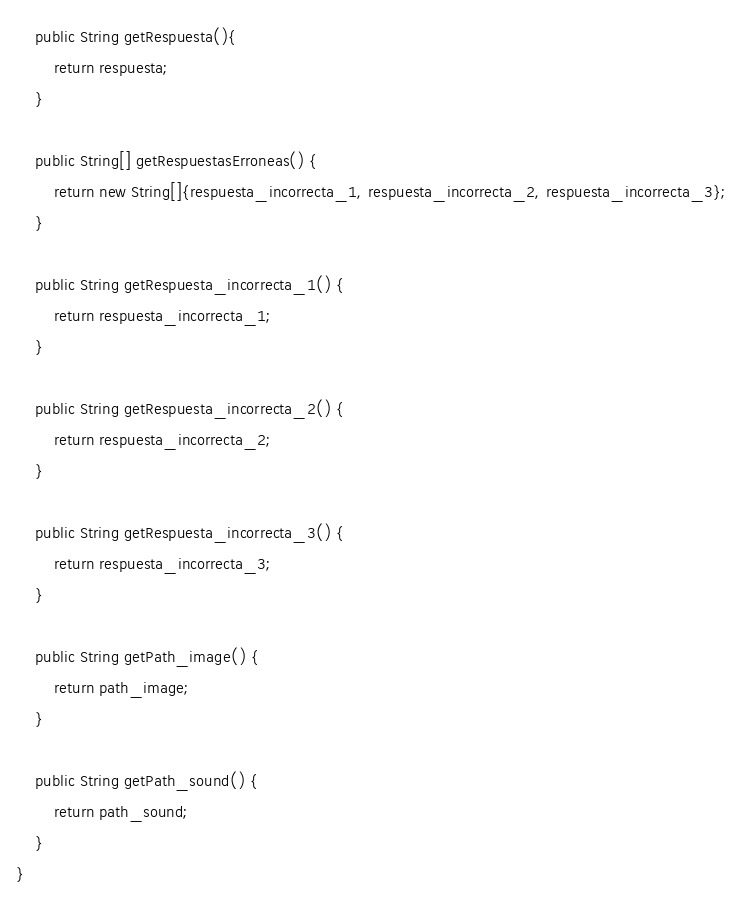Convert code to text. <code><loc_0><loc_0><loc_500><loc_500><_Java_>
    public String getRespuesta(){
        return respuesta;
    }

    public String[] getRespuestasErroneas() {
        return new String[]{respuesta_incorrecta_1, respuesta_incorrecta_2, respuesta_incorrecta_3};
    }

    public String getRespuesta_incorrecta_1() {
        return respuesta_incorrecta_1;
    }

    public String getRespuesta_incorrecta_2() {
        return respuesta_incorrecta_2;
    }

    public String getRespuesta_incorrecta_3() {
        return respuesta_incorrecta_3;
    }

    public String getPath_image() {
        return path_image;
    }

    public String getPath_sound() {
        return path_sound;
    }
}
</code> 